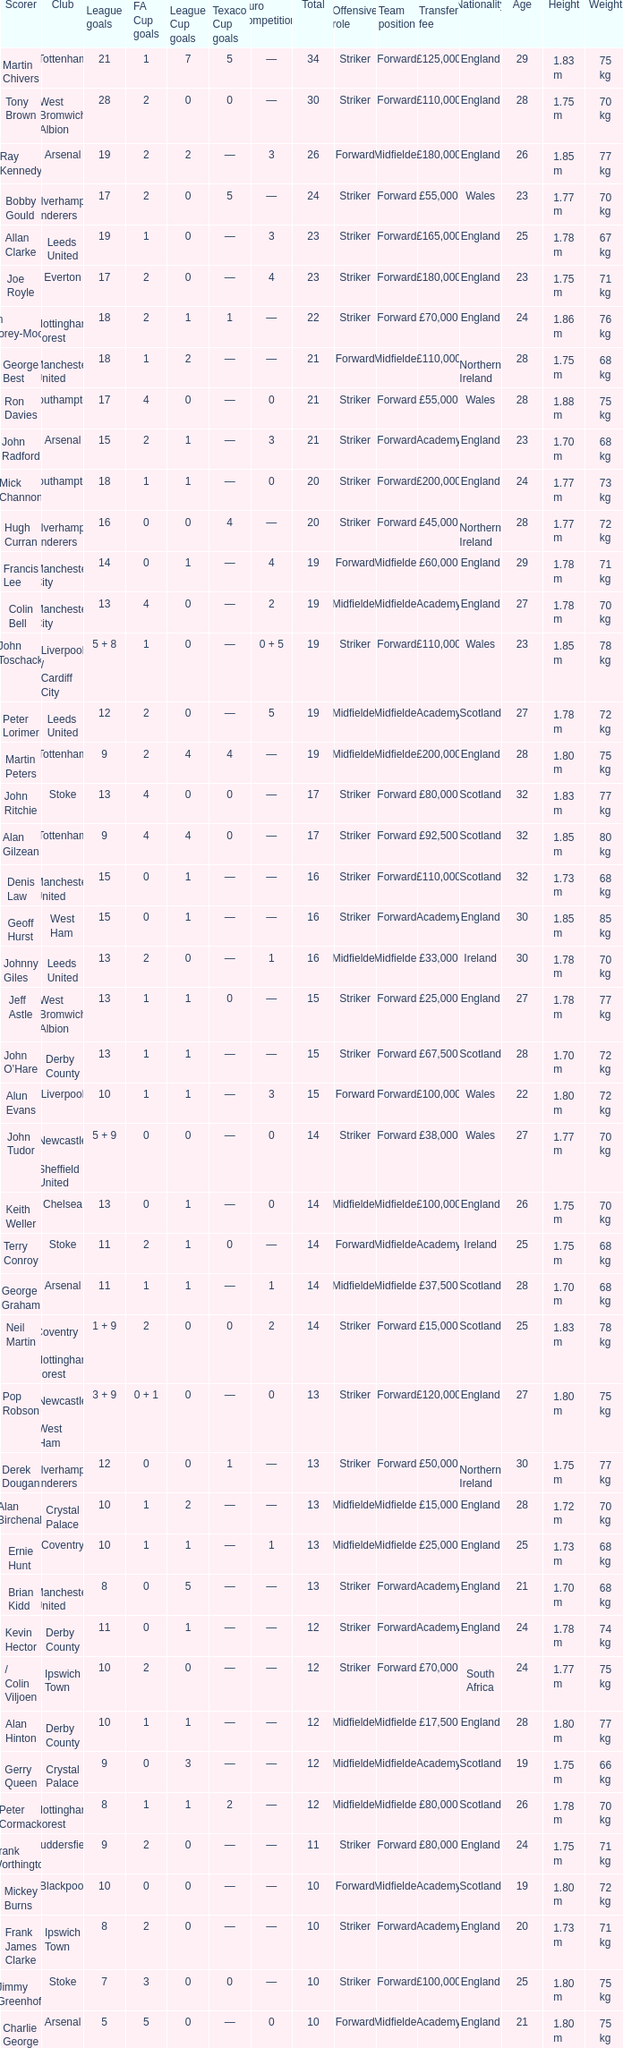What is the lowest League Cup Goals, when Scorer is Denis Law? 1.0. 